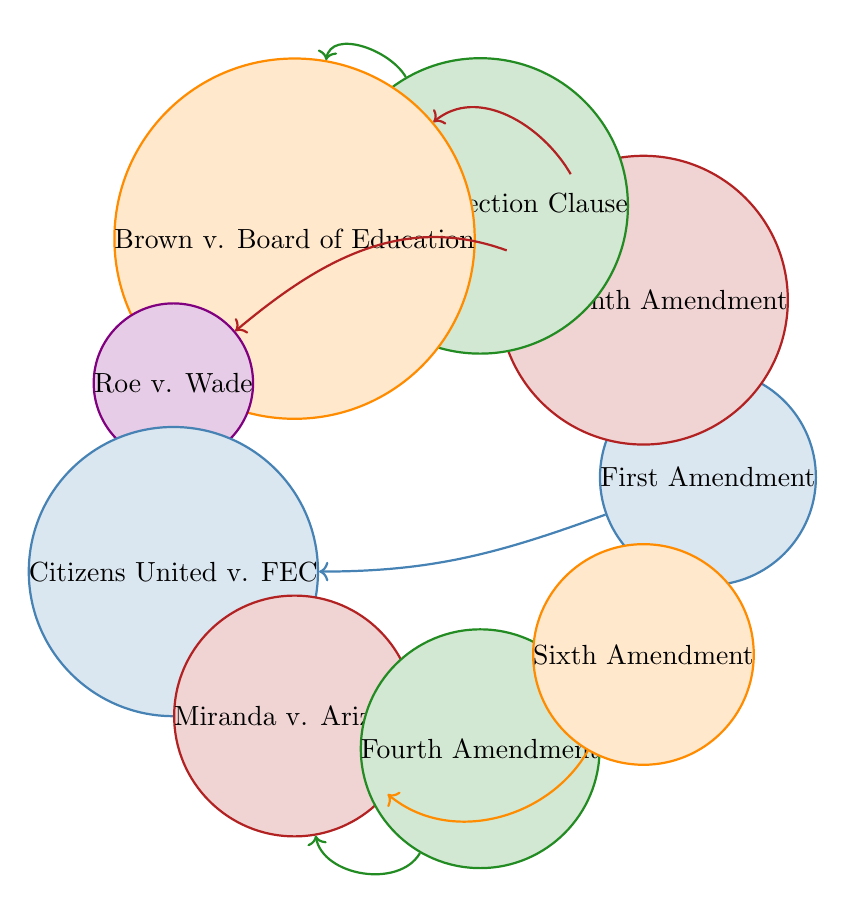What is the total number of nodes in the diagram? The diagram contains a list of nodes, which includes "First Amendment," "Fourteenth Amendment," "Equal Protection Clause," "Brown v. Board of Education," "Roe v. Wade," "Citizens United v. FEC," "Miranda v. Arizona," "Fourth Amendment," and "Sixth Amendment." Counting these, we see there are 9 nodes in total.
Answer: 9 Which Supreme Court case is linked to the First Amendment? The diagram shows a link originating from the "First Amendment" node pointing to "Citizens United v. FEC." Therefore, the Supreme Court case linked to the First Amendment is "Citizens United v. FEC."
Answer: Citizens United v. FEC How many links connect to the Fourteenth Amendment? A careful observation of the links originating from the "Fourteenth Amendment" node reveals two connections: one to "Brown v. Board of Education" and another to "Roe v. Wade." Thus, there are 2 links connecting to the Fourteenth Amendment.
Answer: 2 What is the direct relationship between the Equal Protection Clause and Brown v. Board of Education? According to the diagram, there is a direct link from the "Equal Protection Clause" node to the "Brown v. Board of Education" node, indicating that the Equal Protection Clause is a legal principle applied in this case.
Answer: Direct link Which amendments are linked to Miranda v. Arizona? The diagram illustrates two links that point towards "Miranda v. Arizona," one coming from the "Fourth Amendment" and the other from the "Sixth Amendment." This indicates that both amendments are relevant to Miranda v. Arizona.
Answer: Fourth and Sixth Amendments How many Supreme Court cases are represented in the diagram? The nodes indicating Supreme Court cases are "Brown v. Board of Education," "Roe v. Wade," "Citizens United v. FEC," and "Miranda v. Arizona." Counting these, we find that there are 4 Supreme Court cases represented in the diagram.
Answer: 4 Which amendment is related to both Brown v. Board of Education and Roe v. Wade? The "Fourteenth Amendment" node has direct links to both "Brown v. Board of Education" and "Roe v. Wade." Therefore, the amendment that relates to both cases is the Fourteenth Amendment.
Answer: Fourteenth Amendment Which diagramming approach best represents the influences among Constitutional Amendments and Supreme Court cases in this diagram? The Chord Diagram is utilized here, as it effectively represents the relationships and influences among various nodes by illustrating connections and the frequency or strength of those connections.
Answer: Chord Diagram 